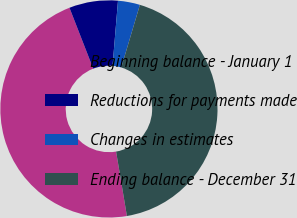Convert chart to OTSL. <chart><loc_0><loc_0><loc_500><loc_500><pie_chart><fcel>Beginning balance - January 1<fcel>Reductions for payments made<fcel>Changes in estimates<fcel>Ending balance - December 31<nl><fcel>46.73%<fcel>7.25%<fcel>3.27%<fcel>42.75%<nl></chart> 